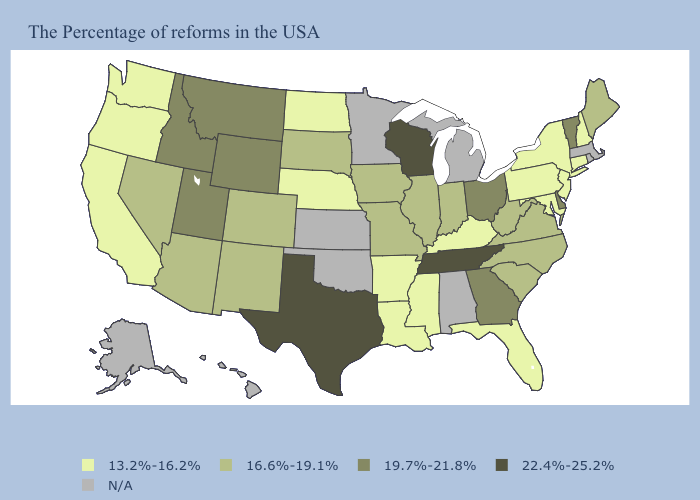What is the lowest value in states that border Missouri?
Be succinct. 13.2%-16.2%. Which states have the lowest value in the USA?
Write a very short answer. New Hampshire, Connecticut, New York, New Jersey, Maryland, Pennsylvania, Florida, Kentucky, Mississippi, Louisiana, Arkansas, Nebraska, North Dakota, California, Washington, Oregon. What is the value of New Jersey?
Answer briefly. 13.2%-16.2%. Among the states that border Rhode Island , which have the highest value?
Concise answer only. Connecticut. Does Wisconsin have the highest value in the USA?
Short answer required. Yes. What is the highest value in the West ?
Quick response, please. 19.7%-21.8%. Which states hav the highest value in the West?
Be succinct. Wyoming, Utah, Montana, Idaho. What is the value of Iowa?
Concise answer only. 16.6%-19.1%. Name the states that have a value in the range 22.4%-25.2%?
Concise answer only. Tennessee, Wisconsin, Texas. Which states have the highest value in the USA?
Concise answer only. Tennessee, Wisconsin, Texas. Does Wisconsin have the lowest value in the USA?
Quick response, please. No. What is the highest value in states that border West Virginia?
Keep it brief. 19.7%-21.8%. Which states have the lowest value in the West?
Concise answer only. California, Washington, Oregon. 